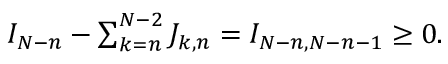<formula> <loc_0><loc_0><loc_500><loc_500>\begin{array} { r } { I _ { N - n } - \sum _ { k = n } ^ { N - 2 } J _ { k , n } = I _ { N - n , N - n - 1 } \geq 0 . } \end{array}</formula> 